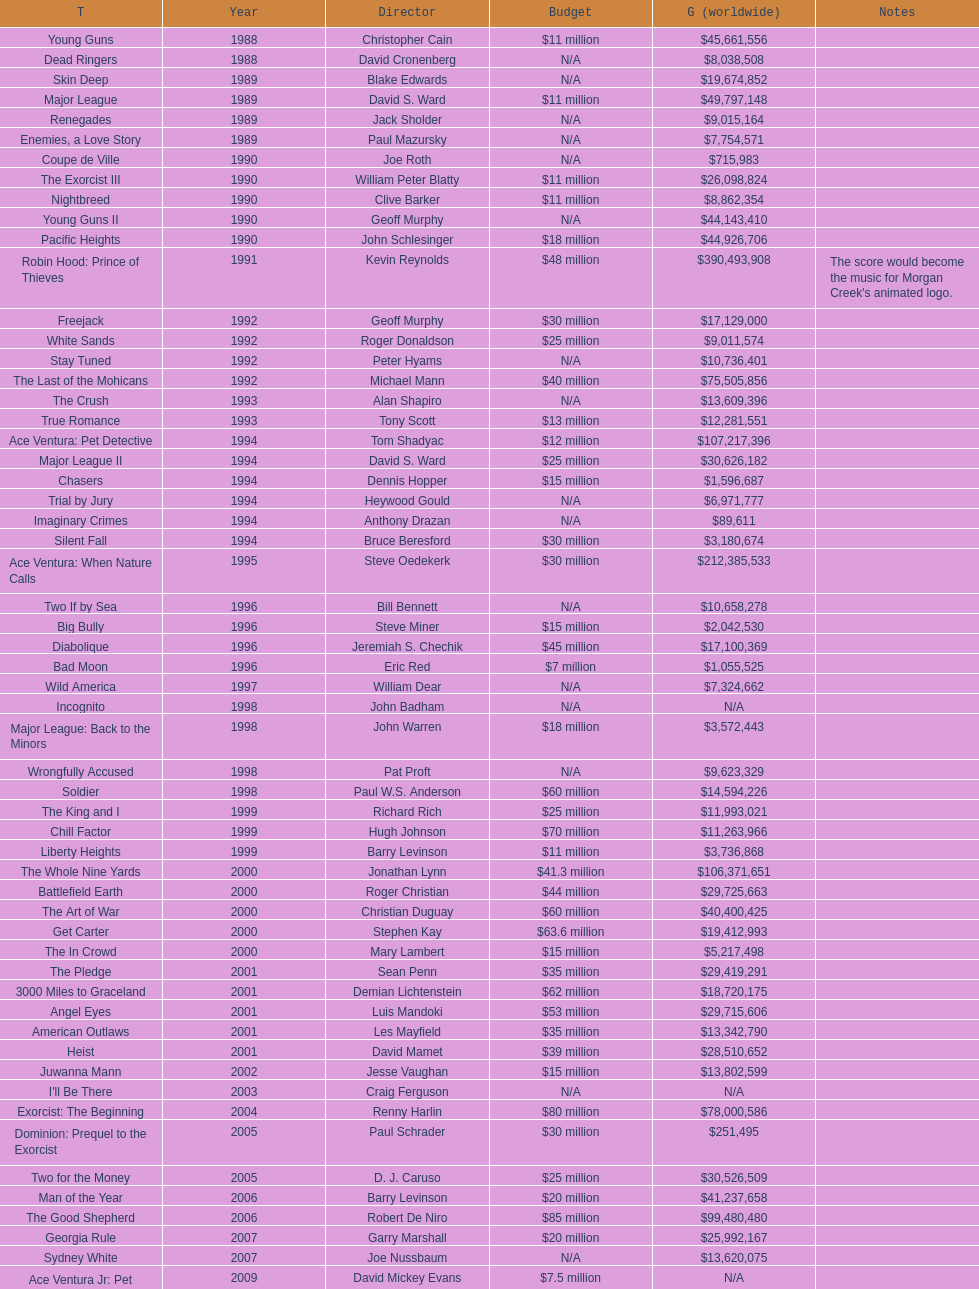What was the sole film with a 48 million dollar budget? Robin Hood: Prince of Thieves. Would you be able to parse every entry in this table? {'header': ['T', 'Year', 'Director', 'Budget', 'G (worldwide)', 'Notes'], 'rows': [['Young Guns', '1988', 'Christopher Cain', '$11 million', '$45,661,556', ''], ['Dead Ringers', '1988', 'David Cronenberg', 'N/A', '$8,038,508', ''], ['Skin Deep', '1989', 'Blake Edwards', 'N/A', '$19,674,852', ''], ['Major League', '1989', 'David S. Ward', '$11 million', '$49,797,148', ''], ['Renegades', '1989', 'Jack Sholder', 'N/A', '$9,015,164', ''], ['Enemies, a Love Story', '1989', 'Paul Mazursky', 'N/A', '$7,754,571', ''], ['Coupe de Ville', '1990', 'Joe Roth', 'N/A', '$715,983', ''], ['The Exorcist III', '1990', 'William Peter Blatty', '$11 million', '$26,098,824', ''], ['Nightbreed', '1990', 'Clive Barker', '$11 million', '$8,862,354', ''], ['Young Guns II', '1990', 'Geoff Murphy', 'N/A', '$44,143,410', ''], ['Pacific Heights', '1990', 'John Schlesinger', '$18 million', '$44,926,706', ''], ['Robin Hood: Prince of Thieves', '1991', 'Kevin Reynolds', '$48 million', '$390,493,908', "The score would become the music for Morgan Creek's animated logo."], ['Freejack', '1992', 'Geoff Murphy', '$30 million', '$17,129,000', ''], ['White Sands', '1992', 'Roger Donaldson', '$25 million', '$9,011,574', ''], ['Stay Tuned', '1992', 'Peter Hyams', 'N/A', '$10,736,401', ''], ['The Last of the Mohicans', '1992', 'Michael Mann', '$40 million', '$75,505,856', ''], ['The Crush', '1993', 'Alan Shapiro', 'N/A', '$13,609,396', ''], ['True Romance', '1993', 'Tony Scott', '$13 million', '$12,281,551', ''], ['Ace Ventura: Pet Detective', '1994', 'Tom Shadyac', '$12 million', '$107,217,396', ''], ['Major League II', '1994', 'David S. Ward', '$25 million', '$30,626,182', ''], ['Chasers', '1994', 'Dennis Hopper', '$15 million', '$1,596,687', ''], ['Trial by Jury', '1994', 'Heywood Gould', 'N/A', '$6,971,777', ''], ['Imaginary Crimes', '1994', 'Anthony Drazan', 'N/A', '$89,611', ''], ['Silent Fall', '1994', 'Bruce Beresford', '$30 million', '$3,180,674', ''], ['Ace Ventura: When Nature Calls', '1995', 'Steve Oedekerk', '$30 million', '$212,385,533', ''], ['Two If by Sea', '1996', 'Bill Bennett', 'N/A', '$10,658,278', ''], ['Big Bully', '1996', 'Steve Miner', '$15 million', '$2,042,530', ''], ['Diabolique', '1996', 'Jeremiah S. Chechik', '$45 million', '$17,100,369', ''], ['Bad Moon', '1996', 'Eric Red', '$7 million', '$1,055,525', ''], ['Wild America', '1997', 'William Dear', 'N/A', '$7,324,662', ''], ['Incognito', '1998', 'John Badham', 'N/A', 'N/A', ''], ['Major League: Back to the Minors', '1998', 'John Warren', '$18 million', '$3,572,443', ''], ['Wrongfully Accused', '1998', 'Pat Proft', 'N/A', '$9,623,329', ''], ['Soldier', '1998', 'Paul W.S. Anderson', '$60 million', '$14,594,226', ''], ['The King and I', '1999', 'Richard Rich', '$25 million', '$11,993,021', ''], ['Chill Factor', '1999', 'Hugh Johnson', '$70 million', '$11,263,966', ''], ['Liberty Heights', '1999', 'Barry Levinson', '$11 million', '$3,736,868', ''], ['The Whole Nine Yards', '2000', 'Jonathan Lynn', '$41.3 million', '$106,371,651', ''], ['Battlefield Earth', '2000', 'Roger Christian', '$44 million', '$29,725,663', ''], ['The Art of War', '2000', 'Christian Duguay', '$60 million', '$40,400,425', ''], ['Get Carter', '2000', 'Stephen Kay', '$63.6 million', '$19,412,993', ''], ['The In Crowd', '2000', 'Mary Lambert', '$15 million', '$5,217,498', ''], ['The Pledge', '2001', 'Sean Penn', '$35 million', '$29,419,291', ''], ['3000 Miles to Graceland', '2001', 'Demian Lichtenstein', '$62 million', '$18,720,175', ''], ['Angel Eyes', '2001', 'Luis Mandoki', '$53 million', '$29,715,606', ''], ['American Outlaws', '2001', 'Les Mayfield', '$35 million', '$13,342,790', ''], ['Heist', '2001', 'David Mamet', '$39 million', '$28,510,652', ''], ['Juwanna Mann', '2002', 'Jesse Vaughan', '$15 million', '$13,802,599', ''], ["I'll Be There", '2003', 'Craig Ferguson', 'N/A', 'N/A', ''], ['Exorcist: The Beginning', '2004', 'Renny Harlin', '$80 million', '$78,000,586', ''], ['Dominion: Prequel to the Exorcist', '2005', 'Paul Schrader', '$30 million', '$251,495', ''], ['Two for the Money', '2005', 'D. J. Caruso', '$25 million', '$30,526,509', ''], ['Man of the Year', '2006', 'Barry Levinson', '$20 million', '$41,237,658', ''], ['The Good Shepherd', '2006', 'Robert De Niro', '$85 million', '$99,480,480', ''], ['Georgia Rule', '2007', 'Garry Marshall', '$20 million', '$25,992,167', ''], ['Sydney White', '2007', 'Joe Nussbaum', 'N/A', '$13,620,075', ''], ['Ace Ventura Jr: Pet Detective', '2009', 'David Mickey Evans', '$7.5 million', 'N/A', ''], ['Dream House', '2011', 'Jim Sheridan', '$50 million', '$38,502,340', ''], ['The Thing', '2011', 'Matthijs van Heijningen Jr.', '$38 million', '$27,428,670', ''], ['Tupac', '2014', 'Antoine Fuqua', '$45 million', '', '']]} 